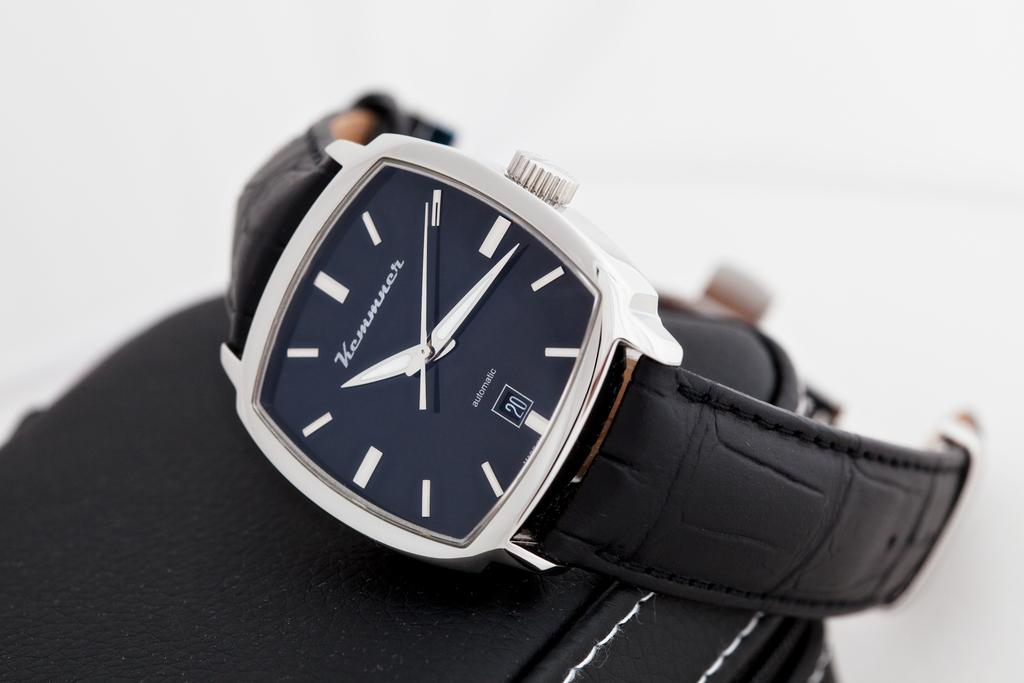<image>
Provide a brief description of the given image. a watch that has the number 20 on it 